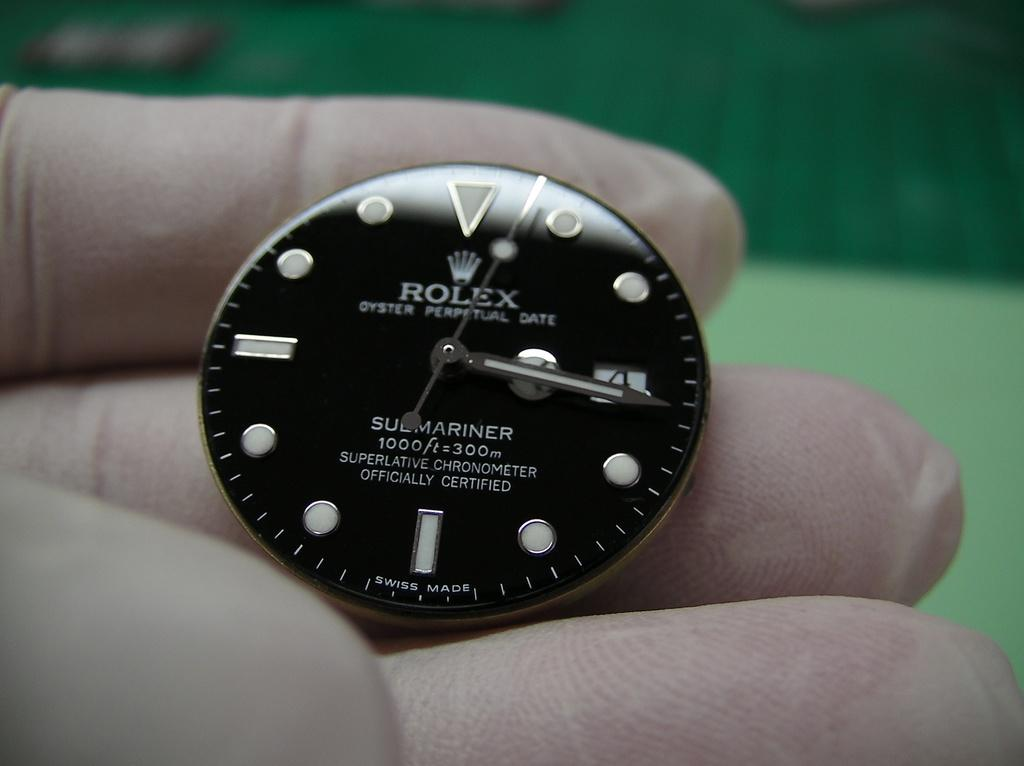Provide a one-sentence caption for the provided image. A rolex watch on someone's hand wearing white gloves. 